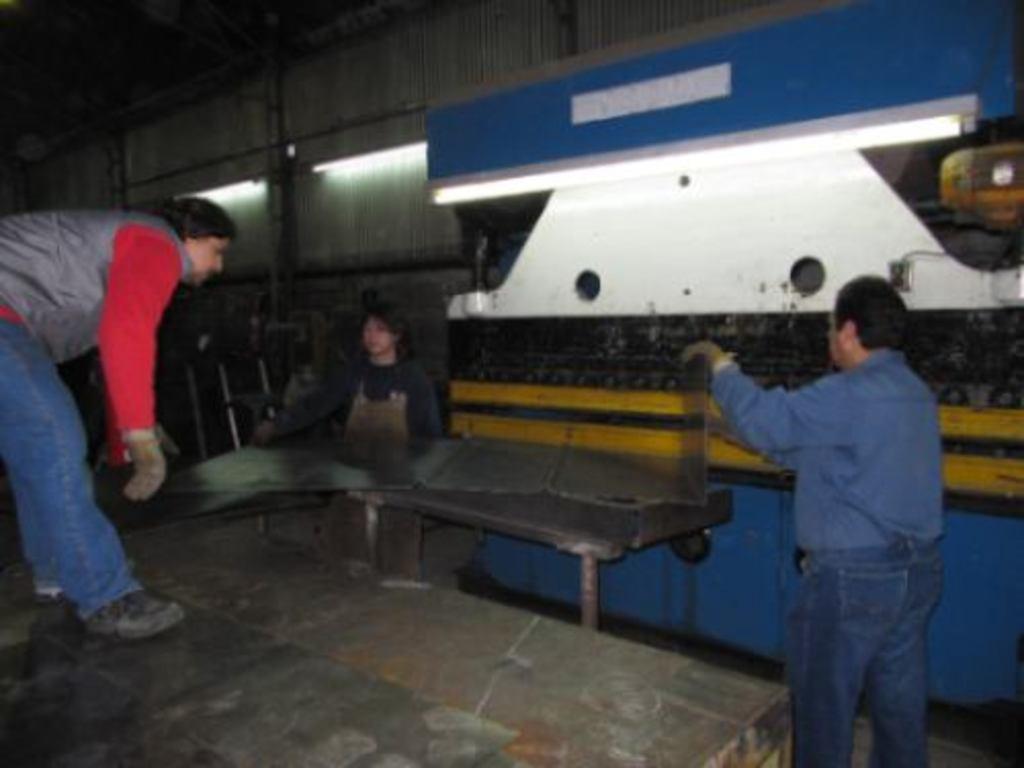Can you describe this image briefly? In this image there are persons standing and there is an object which is blue and white in colour and in the center there is a table, on the table there is an object. In the background there are lights on the wall. 